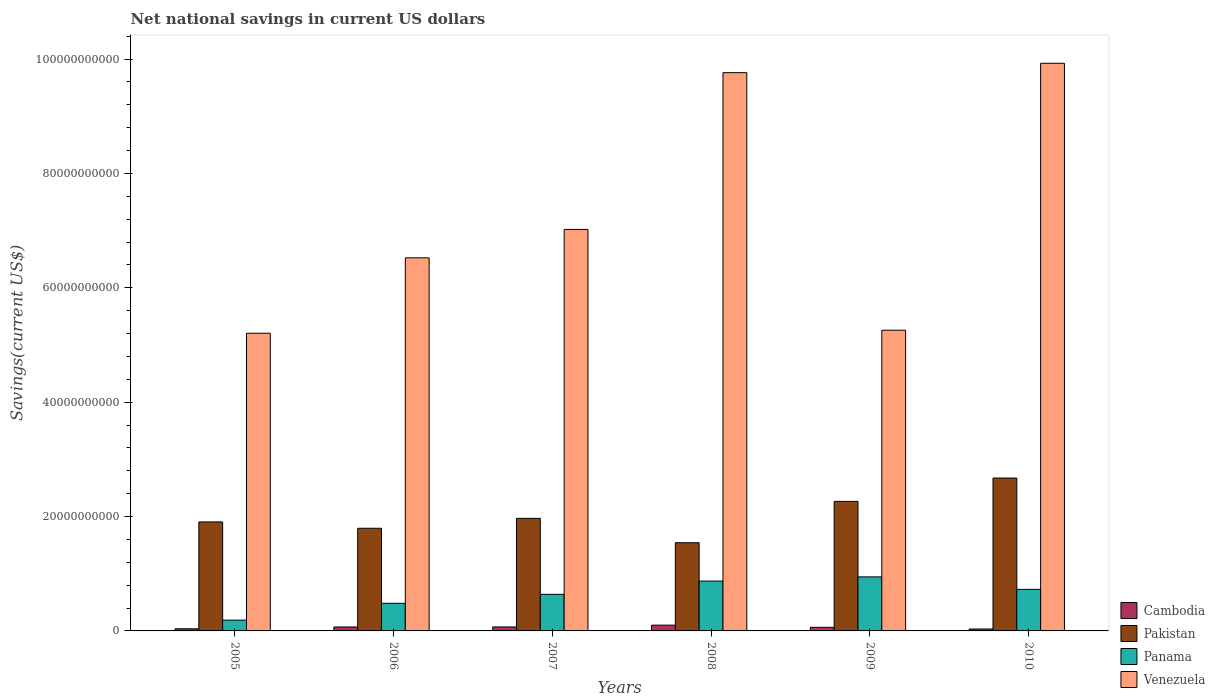How many groups of bars are there?
Provide a short and direct response. 6. Are the number of bars on each tick of the X-axis equal?
Provide a short and direct response. Yes. In how many cases, is the number of bars for a given year not equal to the number of legend labels?
Keep it short and to the point. 0. What is the net national savings in Venezuela in 2008?
Your answer should be compact. 9.76e+1. Across all years, what is the maximum net national savings in Pakistan?
Offer a terse response. 2.67e+1. Across all years, what is the minimum net national savings in Cambodia?
Your answer should be compact. 3.38e+08. In which year was the net national savings in Cambodia minimum?
Provide a succinct answer. 2010. What is the total net national savings in Panama in the graph?
Keep it short and to the point. 3.85e+1. What is the difference between the net national savings in Pakistan in 2006 and that in 2008?
Your answer should be very brief. 2.53e+09. What is the difference between the net national savings in Panama in 2005 and the net national savings in Venezuela in 2006?
Your answer should be very brief. -6.33e+1. What is the average net national savings in Pakistan per year?
Give a very brief answer. 2.02e+1. In the year 2008, what is the difference between the net national savings in Cambodia and net national savings in Pakistan?
Offer a very short reply. -1.44e+1. In how many years, is the net national savings in Cambodia greater than 88000000000 US$?
Give a very brief answer. 0. What is the ratio of the net national savings in Cambodia in 2006 to that in 2009?
Give a very brief answer. 1.09. Is the net national savings in Pakistan in 2008 less than that in 2010?
Give a very brief answer. Yes. What is the difference between the highest and the second highest net national savings in Venezuela?
Give a very brief answer. 1.64e+09. What is the difference between the highest and the lowest net national savings in Venezuela?
Make the answer very short. 4.72e+1. In how many years, is the net national savings in Venezuela greater than the average net national savings in Venezuela taken over all years?
Your answer should be very brief. 2. What does the 2nd bar from the right in 2006 represents?
Your answer should be compact. Panama. Is it the case that in every year, the sum of the net national savings in Cambodia and net national savings in Panama is greater than the net national savings in Venezuela?
Keep it short and to the point. No. How many bars are there?
Offer a very short reply. 24. Are all the bars in the graph horizontal?
Your response must be concise. No. What is the difference between two consecutive major ticks on the Y-axis?
Ensure brevity in your answer.  2.00e+1. Does the graph contain grids?
Keep it short and to the point. No. What is the title of the graph?
Your response must be concise. Net national savings in current US dollars. What is the label or title of the Y-axis?
Ensure brevity in your answer.  Savings(current US$). What is the Savings(current US$) in Cambodia in 2005?
Your response must be concise. 3.74e+08. What is the Savings(current US$) of Pakistan in 2005?
Your response must be concise. 1.91e+1. What is the Savings(current US$) of Panama in 2005?
Provide a succinct answer. 1.89e+09. What is the Savings(current US$) in Venezuela in 2005?
Provide a short and direct response. 5.20e+1. What is the Savings(current US$) in Cambodia in 2006?
Your answer should be compact. 6.89e+08. What is the Savings(current US$) in Pakistan in 2006?
Offer a very short reply. 1.79e+1. What is the Savings(current US$) of Panama in 2006?
Offer a very short reply. 4.83e+09. What is the Savings(current US$) of Venezuela in 2006?
Offer a very short reply. 6.52e+1. What is the Savings(current US$) in Cambodia in 2007?
Your answer should be compact. 6.94e+08. What is the Savings(current US$) of Pakistan in 2007?
Your response must be concise. 1.97e+1. What is the Savings(current US$) of Panama in 2007?
Provide a succinct answer. 6.40e+09. What is the Savings(current US$) in Venezuela in 2007?
Provide a short and direct response. 7.02e+1. What is the Savings(current US$) in Cambodia in 2008?
Ensure brevity in your answer.  1.01e+09. What is the Savings(current US$) in Pakistan in 2008?
Give a very brief answer. 1.54e+1. What is the Savings(current US$) of Panama in 2008?
Keep it short and to the point. 8.71e+09. What is the Savings(current US$) in Venezuela in 2008?
Provide a short and direct response. 9.76e+1. What is the Savings(current US$) in Cambodia in 2009?
Your answer should be very brief. 6.31e+08. What is the Savings(current US$) of Pakistan in 2009?
Keep it short and to the point. 2.26e+1. What is the Savings(current US$) in Panama in 2009?
Provide a short and direct response. 9.45e+09. What is the Savings(current US$) in Venezuela in 2009?
Keep it short and to the point. 5.26e+1. What is the Savings(current US$) of Cambodia in 2010?
Give a very brief answer. 3.38e+08. What is the Savings(current US$) of Pakistan in 2010?
Your response must be concise. 2.67e+1. What is the Savings(current US$) of Panama in 2010?
Your answer should be compact. 7.27e+09. What is the Savings(current US$) in Venezuela in 2010?
Offer a very short reply. 9.93e+1. Across all years, what is the maximum Savings(current US$) of Cambodia?
Provide a succinct answer. 1.01e+09. Across all years, what is the maximum Savings(current US$) in Pakistan?
Keep it short and to the point. 2.67e+1. Across all years, what is the maximum Savings(current US$) of Panama?
Your answer should be compact. 9.45e+09. Across all years, what is the maximum Savings(current US$) in Venezuela?
Offer a terse response. 9.93e+1. Across all years, what is the minimum Savings(current US$) of Cambodia?
Offer a terse response. 3.38e+08. Across all years, what is the minimum Savings(current US$) of Pakistan?
Your response must be concise. 1.54e+1. Across all years, what is the minimum Savings(current US$) of Panama?
Make the answer very short. 1.89e+09. Across all years, what is the minimum Savings(current US$) in Venezuela?
Offer a very short reply. 5.20e+1. What is the total Savings(current US$) in Cambodia in the graph?
Your answer should be very brief. 3.74e+09. What is the total Savings(current US$) of Pakistan in the graph?
Make the answer very short. 1.21e+11. What is the total Savings(current US$) in Panama in the graph?
Your answer should be compact. 3.85e+1. What is the total Savings(current US$) in Venezuela in the graph?
Keep it short and to the point. 4.37e+11. What is the difference between the Savings(current US$) in Cambodia in 2005 and that in 2006?
Your answer should be compact. -3.15e+08. What is the difference between the Savings(current US$) in Pakistan in 2005 and that in 2006?
Your answer should be compact. 1.11e+09. What is the difference between the Savings(current US$) of Panama in 2005 and that in 2006?
Offer a terse response. -2.94e+09. What is the difference between the Savings(current US$) of Venezuela in 2005 and that in 2006?
Provide a succinct answer. -1.32e+1. What is the difference between the Savings(current US$) in Cambodia in 2005 and that in 2007?
Provide a short and direct response. -3.20e+08. What is the difference between the Savings(current US$) in Pakistan in 2005 and that in 2007?
Give a very brief answer. -6.23e+08. What is the difference between the Savings(current US$) of Panama in 2005 and that in 2007?
Offer a very short reply. -4.51e+09. What is the difference between the Savings(current US$) of Venezuela in 2005 and that in 2007?
Provide a short and direct response. -1.82e+1. What is the difference between the Savings(current US$) of Cambodia in 2005 and that in 2008?
Provide a short and direct response. -6.35e+08. What is the difference between the Savings(current US$) of Pakistan in 2005 and that in 2008?
Provide a short and direct response. 3.64e+09. What is the difference between the Savings(current US$) of Panama in 2005 and that in 2008?
Give a very brief answer. -6.82e+09. What is the difference between the Savings(current US$) of Venezuela in 2005 and that in 2008?
Keep it short and to the point. -4.56e+1. What is the difference between the Savings(current US$) of Cambodia in 2005 and that in 2009?
Keep it short and to the point. -2.57e+08. What is the difference between the Savings(current US$) in Pakistan in 2005 and that in 2009?
Offer a very short reply. -3.59e+09. What is the difference between the Savings(current US$) in Panama in 2005 and that in 2009?
Provide a short and direct response. -7.56e+09. What is the difference between the Savings(current US$) of Venezuela in 2005 and that in 2009?
Offer a very short reply. -5.31e+08. What is the difference between the Savings(current US$) of Cambodia in 2005 and that in 2010?
Provide a short and direct response. 3.62e+07. What is the difference between the Savings(current US$) in Pakistan in 2005 and that in 2010?
Your response must be concise. -7.67e+09. What is the difference between the Savings(current US$) in Panama in 2005 and that in 2010?
Make the answer very short. -5.38e+09. What is the difference between the Savings(current US$) in Venezuela in 2005 and that in 2010?
Ensure brevity in your answer.  -4.72e+1. What is the difference between the Savings(current US$) in Cambodia in 2006 and that in 2007?
Offer a terse response. -5.39e+06. What is the difference between the Savings(current US$) of Pakistan in 2006 and that in 2007?
Your answer should be compact. -1.73e+09. What is the difference between the Savings(current US$) of Panama in 2006 and that in 2007?
Your response must be concise. -1.57e+09. What is the difference between the Savings(current US$) of Venezuela in 2006 and that in 2007?
Your response must be concise. -4.97e+09. What is the difference between the Savings(current US$) in Cambodia in 2006 and that in 2008?
Your answer should be compact. -3.21e+08. What is the difference between the Savings(current US$) in Pakistan in 2006 and that in 2008?
Ensure brevity in your answer.  2.53e+09. What is the difference between the Savings(current US$) in Panama in 2006 and that in 2008?
Offer a very short reply. -3.88e+09. What is the difference between the Savings(current US$) in Venezuela in 2006 and that in 2008?
Give a very brief answer. -3.24e+1. What is the difference between the Savings(current US$) of Cambodia in 2006 and that in 2009?
Give a very brief answer. 5.73e+07. What is the difference between the Savings(current US$) of Pakistan in 2006 and that in 2009?
Make the answer very short. -4.70e+09. What is the difference between the Savings(current US$) of Panama in 2006 and that in 2009?
Your answer should be very brief. -4.62e+09. What is the difference between the Savings(current US$) of Venezuela in 2006 and that in 2009?
Offer a very short reply. 1.27e+1. What is the difference between the Savings(current US$) of Cambodia in 2006 and that in 2010?
Make the answer very short. 3.51e+08. What is the difference between the Savings(current US$) of Pakistan in 2006 and that in 2010?
Offer a very short reply. -8.78e+09. What is the difference between the Savings(current US$) in Panama in 2006 and that in 2010?
Your answer should be very brief. -2.43e+09. What is the difference between the Savings(current US$) in Venezuela in 2006 and that in 2010?
Ensure brevity in your answer.  -3.40e+1. What is the difference between the Savings(current US$) in Cambodia in 2007 and that in 2008?
Provide a succinct answer. -3.15e+08. What is the difference between the Savings(current US$) of Pakistan in 2007 and that in 2008?
Provide a succinct answer. 4.26e+09. What is the difference between the Savings(current US$) of Panama in 2007 and that in 2008?
Ensure brevity in your answer.  -2.31e+09. What is the difference between the Savings(current US$) in Venezuela in 2007 and that in 2008?
Give a very brief answer. -2.74e+1. What is the difference between the Savings(current US$) of Cambodia in 2007 and that in 2009?
Offer a very short reply. 6.27e+07. What is the difference between the Savings(current US$) in Pakistan in 2007 and that in 2009?
Ensure brevity in your answer.  -2.97e+09. What is the difference between the Savings(current US$) of Panama in 2007 and that in 2009?
Your answer should be compact. -3.05e+09. What is the difference between the Savings(current US$) of Venezuela in 2007 and that in 2009?
Your answer should be compact. 1.76e+1. What is the difference between the Savings(current US$) in Cambodia in 2007 and that in 2010?
Provide a short and direct response. 3.56e+08. What is the difference between the Savings(current US$) in Pakistan in 2007 and that in 2010?
Offer a terse response. -7.05e+09. What is the difference between the Savings(current US$) of Panama in 2007 and that in 2010?
Offer a terse response. -8.69e+08. What is the difference between the Savings(current US$) in Venezuela in 2007 and that in 2010?
Make the answer very short. -2.91e+1. What is the difference between the Savings(current US$) of Cambodia in 2008 and that in 2009?
Offer a terse response. 3.78e+08. What is the difference between the Savings(current US$) in Pakistan in 2008 and that in 2009?
Offer a terse response. -7.23e+09. What is the difference between the Savings(current US$) of Panama in 2008 and that in 2009?
Give a very brief answer. -7.36e+08. What is the difference between the Savings(current US$) of Venezuela in 2008 and that in 2009?
Provide a succinct answer. 4.50e+1. What is the difference between the Savings(current US$) in Cambodia in 2008 and that in 2010?
Your answer should be very brief. 6.71e+08. What is the difference between the Savings(current US$) in Pakistan in 2008 and that in 2010?
Offer a very short reply. -1.13e+1. What is the difference between the Savings(current US$) of Panama in 2008 and that in 2010?
Offer a very short reply. 1.45e+09. What is the difference between the Savings(current US$) of Venezuela in 2008 and that in 2010?
Offer a terse response. -1.64e+09. What is the difference between the Savings(current US$) of Cambodia in 2009 and that in 2010?
Ensure brevity in your answer.  2.93e+08. What is the difference between the Savings(current US$) in Pakistan in 2009 and that in 2010?
Ensure brevity in your answer.  -4.08e+09. What is the difference between the Savings(current US$) of Panama in 2009 and that in 2010?
Give a very brief answer. 2.18e+09. What is the difference between the Savings(current US$) in Venezuela in 2009 and that in 2010?
Ensure brevity in your answer.  -4.67e+1. What is the difference between the Savings(current US$) in Cambodia in 2005 and the Savings(current US$) in Pakistan in 2006?
Ensure brevity in your answer.  -1.76e+1. What is the difference between the Savings(current US$) in Cambodia in 2005 and the Savings(current US$) in Panama in 2006?
Offer a terse response. -4.46e+09. What is the difference between the Savings(current US$) of Cambodia in 2005 and the Savings(current US$) of Venezuela in 2006?
Your response must be concise. -6.49e+1. What is the difference between the Savings(current US$) in Pakistan in 2005 and the Savings(current US$) in Panama in 2006?
Offer a very short reply. 1.42e+1. What is the difference between the Savings(current US$) in Pakistan in 2005 and the Savings(current US$) in Venezuela in 2006?
Ensure brevity in your answer.  -4.62e+1. What is the difference between the Savings(current US$) of Panama in 2005 and the Savings(current US$) of Venezuela in 2006?
Give a very brief answer. -6.33e+1. What is the difference between the Savings(current US$) in Cambodia in 2005 and the Savings(current US$) in Pakistan in 2007?
Provide a succinct answer. -1.93e+1. What is the difference between the Savings(current US$) in Cambodia in 2005 and the Savings(current US$) in Panama in 2007?
Your answer should be very brief. -6.02e+09. What is the difference between the Savings(current US$) in Cambodia in 2005 and the Savings(current US$) in Venezuela in 2007?
Provide a succinct answer. -6.98e+1. What is the difference between the Savings(current US$) in Pakistan in 2005 and the Savings(current US$) in Panama in 2007?
Your answer should be very brief. 1.27e+1. What is the difference between the Savings(current US$) of Pakistan in 2005 and the Savings(current US$) of Venezuela in 2007?
Your answer should be very brief. -5.11e+1. What is the difference between the Savings(current US$) in Panama in 2005 and the Savings(current US$) in Venezuela in 2007?
Your response must be concise. -6.83e+1. What is the difference between the Savings(current US$) in Cambodia in 2005 and the Savings(current US$) in Pakistan in 2008?
Ensure brevity in your answer.  -1.50e+1. What is the difference between the Savings(current US$) of Cambodia in 2005 and the Savings(current US$) of Panama in 2008?
Your answer should be compact. -8.34e+09. What is the difference between the Savings(current US$) of Cambodia in 2005 and the Savings(current US$) of Venezuela in 2008?
Keep it short and to the point. -9.72e+1. What is the difference between the Savings(current US$) in Pakistan in 2005 and the Savings(current US$) in Panama in 2008?
Your answer should be compact. 1.03e+1. What is the difference between the Savings(current US$) of Pakistan in 2005 and the Savings(current US$) of Venezuela in 2008?
Provide a short and direct response. -7.86e+1. What is the difference between the Savings(current US$) of Panama in 2005 and the Savings(current US$) of Venezuela in 2008?
Provide a short and direct response. -9.57e+1. What is the difference between the Savings(current US$) of Cambodia in 2005 and the Savings(current US$) of Pakistan in 2009?
Your answer should be very brief. -2.23e+1. What is the difference between the Savings(current US$) of Cambodia in 2005 and the Savings(current US$) of Panama in 2009?
Give a very brief answer. -9.07e+09. What is the difference between the Savings(current US$) in Cambodia in 2005 and the Savings(current US$) in Venezuela in 2009?
Offer a very short reply. -5.22e+1. What is the difference between the Savings(current US$) of Pakistan in 2005 and the Savings(current US$) of Panama in 2009?
Make the answer very short. 9.61e+09. What is the difference between the Savings(current US$) of Pakistan in 2005 and the Savings(current US$) of Venezuela in 2009?
Your answer should be compact. -3.35e+1. What is the difference between the Savings(current US$) of Panama in 2005 and the Savings(current US$) of Venezuela in 2009?
Ensure brevity in your answer.  -5.07e+1. What is the difference between the Savings(current US$) of Cambodia in 2005 and the Savings(current US$) of Pakistan in 2010?
Offer a very short reply. -2.64e+1. What is the difference between the Savings(current US$) in Cambodia in 2005 and the Savings(current US$) in Panama in 2010?
Make the answer very short. -6.89e+09. What is the difference between the Savings(current US$) in Cambodia in 2005 and the Savings(current US$) in Venezuela in 2010?
Give a very brief answer. -9.89e+1. What is the difference between the Savings(current US$) in Pakistan in 2005 and the Savings(current US$) in Panama in 2010?
Your answer should be compact. 1.18e+1. What is the difference between the Savings(current US$) of Pakistan in 2005 and the Savings(current US$) of Venezuela in 2010?
Make the answer very short. -8.02e+1. What is the difference between the Savings(current US$) in Panama in 2005 and the Savings(current US$) in Venezuela in 2010?
Your response must be concise. -9.74e+1. What is the difference between the Savings(current US$) of Cambodia in 2006 and the Savings(current US$) of Pakistan in 2007?
Ensure brevity in your answer.  -1.90e+1. What is the difference between the Savings(current US$) of Cambodia in 2006 and the Savings(current US$) of Panama in 2007?
Offer a very short reply. -5.71e+09. What is the difference between the Savings(current US$) in Cambodia in 2006 and the Savings(current US$) in Venezuela in 2007?
Give a very brief answer. -6.95e+1. What is the difference between the Savings(current US$) of Pakistan in 2006 and the Savings(current US$) of Panama in 2007?
Give a very brief answer. 1.16e+1. What is the difference between the Savings(current US$) of Pakistan in 2006 and the Savings(current US$) of Venezuela in 2007?
Offer a very short reply. -5.23e+1. What is the difference between the Savings(current US$) in Panama in 2006 and the Savings(current US$) in Venezuela in 2007?
Offer a very short reply. -6.54e+1. What is the difference between the Savings(current US$) of Cambodia in 2006 and the Savings(current US$) of Pakistan in 2008?
Ensure brevity in your answer.  -1.47e+1. What is the difference between the Savings(current US$) in Cambodia in 2006 and the Savings(current US$) in Panama in 2008?
Provide a short and direct response. -8.02e+09. What is the difference between the Savings(current US$) in Cambodia in 2006 and the Savings(current US$) in Venezuela in 2008?
Give a very brief answer. -9.69e+1. What is the difference between the Savings(current US$) in Pakistan in 2006 and the Savings(current US$) in Panama in 2008?
Your answer should be compact. 9.24e+09. What is the difference between the Savings(current US$) in Pakistan in 2006 and the Savings(current US$) in Venezuela in 2008?
Make the answer very short. -7.97e+1. What is the difference between the Savings(current US$) of Panama in 2006 and the Savings(current US$) of Venezuela in 2008?
Your answer should be compact. -9.28e+1. What is the difference between the Savings(current US$) in Cambodia in 2006 and the Savings(current US$) in Pakistan in 2009?
Your response must be concise. -2.20e+1. What is the difference between the Savings(current US$) in Cambodia in 2006 and the Savings(current US$) in Panama in 2009?
Give a very brief answer. -8.76e+09. What is the difference between the Savings(current US$) in Cambodia in 2006 and the Savings(current US$) in Venezuela in 2009?
Make the answer very short. -5.19e+1. What is the difference between the Savings(current US$) of Pakistan in 2006 and the Savings(current US$) of Panama in 2009?
Provide a succinct answer. 8.50e+09. What is the difference between the Savings(current US$) in Pakistan in 2006 and the Savings(current US$) in Venezuela in 2009?
Your answer should be compact. -3.46e+1. What is the difference between the Savings(current US$) of Panama in 2006 and the Savings(current US$) of Venezuela in 2009?
Offer a terse response. -4.77e+1. What is the difference between the Savings(current US$) of Cambodia in 2006 and the Savings(current US$) of Pakistan in 2010?
Your answer should be very brief. -2.60e+1. What is the difference between the Savings(current US$) in Cambodia in 2006 and the Savings(current US$) in Panama in 2010?
Your answer should be very brief. -6.58e+09. What is the difference between the Savings(current US$) of Cambodia in 2006 and the Savings(current US$) of Venezuela in 2010?
Your answer should be compact. -9.86e+1. What is the difference between the Savings(current US$) of Pakistan in 2006 and the Savings(current US$) of Panama in 2010?
Give a very brief answer. 1.07e+1. What is the difference between the Savings(current US$) of Pakistan in 2006 and the Savings(current US$) of Venezuela in 2010?
Provide a succinct answer. -8.13e+1. What is the difference between the Savings(current US$) of Panama in 2006 and the Savings(current US$) of Venezuela in 2010?
Offer a terse response. -9.44e+1. What is the difference between the Savings(current US$) of Cambodia in 2007 and the Savings(current US$) of Pakistan in 2008?
Make the answer very short. -1.47e+1. What is the difference between the Savings(current US$) in Cambodia in 2007 and the Savings(current US$) in Panama in 2008?
Offer a very short reply. -8.02e+09. What is the difference between the Savings(current US$) in Cambodia in 2007 and the Savings(current US$) in Venezuela in 2008?
Your answer should be very brief. -9.69e+1. What is the difference between the Savings(current US$) of Pakistan in 2007 and the Savings(current US$) of Panama in 2008?
Ensure brevity in your answer.  1.10e+1. What is the difference between the Savings(current US$) in Pakistan in 2007 and the Savings(current US$) in Venezuela in 2008?
Provide a succinct answer. -7.79e+1. What is the difference between the Savings(current US$) in Panama in 2007 and the Savings(current US$) in Venezuela in 2008?
Offer a terse response. -9.12e+1. What is the difference between the Savings(current US$) in Cambodia in 2007 and the Savings(current US$) in Pakistan in 2009?
Ensure brevity in your answer.  -2.20e+1. What is the difference between the Savings(current US$) of Cambodia in 2007 and the Savings(current US$) of Panama in 2009?
Ensure brevity in your answer.  -8.75e+09. What is the difference between the Savings(current US$) in Cambodia in 2007 and the Savings(current US$) in Venezuela in 2009?
Offer a very short reply. -5.19e+1. What is the difference between the Savings(current US$) of Pakistan in 2007 and the Savings(current US$) of Panama in 2009?
Provide a short and direct response. 1.02e+1. What is the difference between the Savings(current US$) in Pakistan in 2007 and the Savings(current US$) in Venezuela in 2009?
Make the answer very short. -3.29e+1. What is the difference between the Savings(current US$) of Panama in 2007 and the Savings(current US$) of Venezuela in 2009?
Ensure brevity in your answer.  -4.62e+1. What is the difference between the Savings(current US$) in Cambodia in 2007 and the Savings(current US$) in Pakistan in 2010?
Offer a terse response. -2.60e+1. What is the difference between the Savings(current US$) in Cambodia in 2007 and the Savings(current US$) in Panama in 2010?
Provide a short and direct response. -6.57e+09. What is the difference between the Savings(current US$) in Cambodia in 2007 and the Savings(current US$) in Venezuela in 2010?
Your answer should be compact. -9.86e+1. What is the difference between the Savings(current US$) in Pakistan in 2007 and the Savings(current US$) in Panama in 2010?
Your answer should be compact. 1.24e+1. What is the difference between the Savings(current US$) of Pakistan in 2007 and the Savings(current US$) of Venezuela in 2010?
Keep it short and to the point. -7.96e+1. What is the difference between the Savings(current US$) in Panama in 2007 and the Savings(current US$) in Venezuela in 2010?
Provide a succinct answer. -9.29e+1. What is the difference between the Savings(current US$) of Cambodia in 2008 and the Savings(current US$) of Pakistan in 2009?
Your answer should be compact. -2.16e+1. What is the difference between the Savings(current US$) in Cambodia in 2008 and the Savings(current US$) in Panama in 2009?
Keep it short and to the point. -8.44e+09. What is the difference between the Savings(current US$) of Cambodia in 2008 and the Savings(current US$) of Venezuela in 2009?
Ensure brevity in your answer.  -5.16e+1. What is the difference between the Savings(current US$) of Pakistan in 2008 and the Savings(current US$) of Panama in 2009?
Offer a very short reply. 5.97e+09. What is the difference between the Savings(current US$) in Pakistan in 2008 and the Savings(current US$) in Venezuela in 2009?
Provide a short and direct response. -3.72e+1. What is the difference between the Savings(current US$) in Panama in 2008 and the Savings(current US$) in Venezuela in 2009?
Make the answer very short. -4.39e+1. What is the difference between the Savings(current US$) in Cambodia in 2008 and the Savings(current US$) in Pakistan in 2010?
Provide a short and direct response. -2.57e+1. What is the difference between the Savings(current US$) of Cambodia in 2008 and the Savings(current US$) of Panama in 2010?
Give a very brief answer. -6.26e+09. What is the difference between the Savings(current US$) in Cambodia in 2008 and the Savings(current US$) in Venezuela in 2010?
Offer a very short reply. -9.82e+1. What is the difference between the Savings(current US$) of Pakistan in 2008 and the Savings(current US$) of Panama in 2010?
Offer a very short reply. 8.15e+09. What is the difference between the Savings(current US$) of Pakistan in 2008 and the Savings(current US$) of Venezuela in 2010?
Keep it short and to the point. -8.38e+1. What is the difference between the Savings(current US$) in Panama in 2008 and the Savings(current US$) in Venezuela in 2010?
Your answer should be very brief. -9.05e+1. What is the difference between the Savings(current US$) in Cambodia in 2009 and the Savings(current US$) in Pakistan in 2010?
Provide a succinct answer. -2.61e+1. What is the difference between the Savings(current US$) in Cambodia in 2009 and the Savings(current US$) in Panama in 2010?
Provide a succinct answer. -6.64e+09. What is the difference between the Savings(current US$) in Cambodia in 2009 and the Savings(current US$) in Venezuela in 2010?
Your answer should be compact. -9.86e+1. What is the difference between the Savings(current US$) in Pakistan in 2009 and the Savings(current US$) in Panama in 2010?
Your response must be concise. 1.54e+1. What is the difference between the Savings(current US$) of Pakistan in 2009 and the Savings(current US$) of Venezuela in 2010?
Your answer should be compact. -7.66e+1. What is the difference between the Savings(current US$) of Panama in 2009 and the Savings(current US$) of Venezuela in 2010?
Give a very brief answer. -8.98e+1. What is the average Savings(current US$) in Cambodia per year?
Provide a short and direct response. 6.23e+08. What is the average Savings(current US$) in Pakistan per year?
Your answer should be compact. 2.02e+1. What is the average Savings(current US$) in Panama per year?
Give a very brief answer. 6.42e+09. What is the average Savings(current US$) in Venezuela per year?
Your answer should be very brief. 7.28e+1. In the year 2005, what is the difference between the Savings(current US$) of Cambodia and Savings(current US$) of Pakistan?
Provide a succinct answer. -1.87e+1. In the year 2005, what is the difference between the Savings(current US$) of Cambodia and Savings(current US$) of Panama?
Provide a succinct answer. -1.52e+09. In the year 2005, what is the difference between the Savings(current US$) in Cambodia and Savings(current US$) in Venezuela?
Provide a short and direct response. -5.17e+1. In the year 2005, what is the difference between the Savings(current US$) of Pakistan and Savings(current US$) of Panama?
Provide a short and direct response. 1.72e+1. In the year 2005, what is the difference between the Savings(current US$) in Pakistan and Savings(current US$) in Venezuela?
Your answer should be very brief. -3.30e+1. In the year 2005, what is the difference between the Savings(current US$) of Panama and Savings(current US$) of Venezuela?
Give a very brief answer. -5.02e+1. In the year 2006, what is the difference between the Savings(current US$) of Cambodia and Savings(current US$) of Pakistan?
Ensure brevity in your answer.  -1.73e+1. In the year 2006, what is the difference between the Savings(current US$) of Cambodia and Savings(current US$) of Panama?
Offer a very short reply. -4.14e+09. In the year 2006, what is the difference between the Savings(current US$) in Cambodia and Savings(current US$) in Venezuela?
Keep it short and to the point. -6.45e+1. In the year 2006, what is the difference between the Savings(current US$) in Pakistan and Savings(current US$) in Panama?
Provide a succinct answer. 1.31e+1. In the year 2006, what is the difference between the Savings(current US$) in Pakistan and Savings(current US$) in Venezuela?
Provide a short and direct response. -4.73e+1. In the year 2006, what is the difference between the Savings(current US$) of Panama and Savings(current US$) of Venezuela?
Give a very brief answer. -6.04e+1. In the year 2007, what is the difference between the Savings(current US$) of Cambodia and Savings(current US$) of Pakistan?
Your answer should be compact. -1.90e+1. In the year 2007, what is the difference between the Savings(current US$) of Cambodia and Savings(current US$) of Panama?
Make the answer very short. -5.70e+09. In the year 2007, what is the difference between the Savings(current US$) in Cambodia and Savings(current US$) in Venezuela?
Your answer should be very brief. -6.95e+1. In the year 2007, what is the difference between the Savings(current US$) of Pakistan and Savings(current US$) of Panama?
Provide a succinct answer. 1.33e+1. In the year 2007, what is the difference between the Savings(current US$) in Pakistan and Savings(current US$) in Venezuela?
Make the answer very short. -5.05e+1. In the year 2007, what is the difference between the Savings(current US$) in Panama and Savings(current US$) in Venezuela?
Make the answer very short. -6.38e+1. In the year 2008, what is the difference between the Savings(current US$) in Cambodia and Savings(current US$) in Pakistan?
Keep it short and to the point. -1.44e+1. In the year 2008, what is the difference between the Savings(current US$) in Cambodia and Savings(current US$) in Panama?
Your response must be concise. -7.70e+09. In the year 2008, what is the difference between the Savings(current US$) of Cambodia and Savings(current US$) of Venezuela?
Keep it short and to the point. -9.66e+1. In the year 2008, what is the difference between the Savings(current US$) in Pakistan and Savings(current US$) in Panama?
Ensure brevity in your answer.  6.71e+09. In the year 2008, what is the difference between the Savings(current US$) of Pakistan and Savings(current US$) of Venezuela?
Offer a terse response. -8.22e+1. In the year 2008, what is the difference between the Savings(current US$) in Panama and Savings(current US$) in Venezuela?
Make the answer very short. -8.89e+1. In the year 2009, what is the difference between the Savings(current US$) of Cambodia and Savings(current US$) of Pakistan?
Make the answer very short. -2.20e+1. In the year 2009, what is the difference between the Savings(current US$) in Cambodia and Savings(current US$) in Panama?
Provide a succinct answer. -8.82e+09. In the year 2009, what is the difference between the Savings(current US$) of Cambodia and Savings(current US$) of Venezuela?
Offer a terse response. -5.19e+1. In the year 2009, what is the difference between the Savings(current US$) in Pakistan and Savings(current US$) in Panama?
Offer a very short reply. 1.32e+1. In the year 2009, what is the difference between the Savings(current US$) in Pakistan and Savings(current US$) in Venezuela?
Keep it short and to the point. -2.99e+1. In the year 2009, what is the difference between the Savings(current US$) of Panama and Savings(current US$) of Venezuela?
Provide a succinct answer. -4.31e+1. In the year 2010, what is the difference between the Savings(current US$) of Cambodia and Savings(current US$) of Pakistan?
Keep it short and to the point. -2.64e+1. In the year 2010, what is the difference between the Savings(current US$) of Cambodia and Savings(current US$) of Panama?
Ensure brevity in your answer.  -6.93e+09. In the year 2010, what is the difference between the Savings(current US$) of Cambodia and Savings(current US$) of Venezuela?
Your answer should be very brief. -9.89e+1. In the year 2010, what is the difference between the Savings(current US$) of Pakistan and Savings(current US$) of Panama?
Keep it short and to the point. 1.95e+1. In the year 2010, what is the difference between the Savings(current US$) of Pakistan and Savings(current US$) of Venezuela?
Provide a short and direct response. -7.25e+1. In the year 2010, what is the difference between the Savings(current US$) of Panama and Savings(current US$) of Venezuela?
Your answer should be very brief. -9.20e+1. What is the ratio of the Savings(current US$) in Cambodia in 2005 to that in 2006?
Your response must be concise. 0.54. What is the ratio of the Savings(current US$) of Pakistan in 2005 to that in 2006?
Provide a short and direct response. 1.06. What is the ratio of the Savings(current US$) of Panama in 2005 to that in 2006?
Your response must be concise. 0.39. What is the ratio of the Savings(current US$) in Venezuela in 2005 to that in 2006?
Provide a short and direct response. 0.8. What is the ratio of the Savings(current US$) of Cambodia in 2005 to that in 2007?
Provide a succinct answer. 0.54. What is the ratio of the Savings(current US$) in Pakistan in 2005 to that in 2007?
Provide a succinct answer. 0.97. What is the ratio of the Savings(current US$) of Panama in 2005 to that in 2007?
Provide a succinct answer. 0.3. What is the ratio of the Savings(current US$) in Venezuela in 2005 to that in 2007?
Keep it short and to the point. 0.74. What is the ratio of the Savings(current US$) of Cambodia in 2005 to that in 2008?
Your answer should be compact. 0.37. What is the ratio of the Savings(current US$) in Pakistan in 2005 to that in 2008?
Offer a very short reply. 1.24. What is the ratio of the Savings(current US$) in Panama in 2005 to that in 2008?
Your answer should be compact. 0.22. What is the ratio of the Savings(current US$) in Venezuela in 2005 to that in 2008?
Give a very brief answer. 0.53. What is the ratio of the Savings(current US$) in Cambodia in 2005 to that in 2009?
Make the answer very short. 0.59. What is the ratio of the Savings(current US$) in Pakistan in 2005 to that in 2009?
Your answer should be compact. 0.84. What is the ratio of the Savings(current US$) in Cambodia in 2005 to that in 2010?
Ensure brevity in your answer.  1.11. What is the ratio of the Savings(current US$) in Pakistan in 2005 to that in 2010?
Make the answer very short. 0.71. What is the ratio of the Savings(current US$) of Panama in 2005 to that in 2010?
Keep it short and to the point. 0.26. What is the ratio of the Savings(current US$) of Venezuela in 2005 to that in 2010?
Give a very brief answer. 0.52. What is the ratio of the Savings(current US$) in Cambodia in 2006 to that in 2007?
Give a very brief answer. 0.99. What is the ratio of the Savings(current US$) in Pakistan in 2006 to that in 2007?
Offer a terse response. 0.91. What is the ratio of the Savings(current US$) of Panama in 2006 to that in 2007?
Keep it short and to the point. 0.76. What is the ratio of the Savings(current US$) in Venezuela in 2006 to that in 2007?
Offer a very short reply. 0.93. What is the ratio of the Savings(current US$) of Cambodia in 2006 to that in 2008?
Your response must be concise. 0.68. What is the ratio of the Savings(current US$) of Pakistan in 2006 to that in 2008?
Offer a very short reply. 1.16. What is the ratio of the Savings(current US$) in Panama in 2006 to that in 2008?
Your answer should be very brief. 0.55. What is the ratio of the Savings(current US$) in Venezuela in 2006 to that in 2008?
Ensure brevity in your answer.  0.67. What is the ratio of the Savings(current US$) of Cambodia in 2006 to that in 2009?
Provide a short and direct response. 1.09. What is the ratio of the Savings(current US$) in Pakistan in 2006 to that in 2009?
Keep it short and to the point. 0.79. What is the ratio of the Savings(current US$) of Panama in 2006 to that in 2009?
Provide a succinct answer. 0.51. What is the ratio of the Savings(current US$) in Venezuela in 2006 to that in 2009?
Provide a succinct answer. 1.24. What is the ratio of the Savings(current US$) in Cambodia in 2006 to that in 2010?
Keep it short and to the point. 2.04. What is the ratio of the Savings(current US$) of Pakistan in 2006 to that in 2010?
Offer a terse response. 0.67. What is the ratio of the Savings(current US$) in Panama in 2006 to that in 2010?
Keep it short and to the point. 0.66. What is the ratio of the Savings(current US$) of Venezuela in 2006 to that in 2010?
Ensure brevity in your answer.  0.66. What is the ratio of the Savings(current US$) of Cambodia in 2007 to that in 2008?
Your response must be concise. 0.69. What is the ratio of the Savings(current US$) in Pakistan in 2007 to that in 2008?
Give a very brief answer. 1.28. What is the ratio of the Savings(current US$) of Panama in 2007 to that in 2008?
Your response must be concise. 0.73. What is the ratio of the Savings(current US$) in Venezuela in 2007 to that in 2008?
Make the answer very short. 0.72. What is the ratio of the Savings(current US$) in Cambodia in 2007 to that in 2009?
Give a very brief answer. 1.1. What is the ratio of the Savings(current US$) in Pakistan in 2007 to that in 2009?
Provide a succinct answer. 0.87. What is the ratio of the Savings(current US$) of Panama in 2007 to that in 2009?
Offer a very short reply. 0.68. What is the ratio of the Savings(current US$) of Venezuela in 2007 to that in 2009?
Offer a very short reply. 1.34. What is the ratio of the Savings(current US$) of Cambodia in 2007 to that in 2010?
Your answer should be very brief. 2.05. What is the ratio of the Savings(current US$) in Pakistan in 2007 to that in 2010?
Offer a terse response. 0.74. What is the ratio of the Savings(current US$) in Panama in 2007 to that in 2010?
Make the answer very short. 0.88. What is the ratio of the Savings(current US$) of Venezuela in 2007 to that in 2010?
Make the answer very short. 0.71. What is the ratio of the Savings(current US$) in Cambodia in 2008 to that in 2009?
Make the answer very short. 1.6. What is the ratio of the Savings(current US$) in Pakistan in 2008 to that in 2009?
Provide a succinct answer. 0.68. What is the ratio of the Savings(current US$) of Panama in 2008 to that in 2009?
Your answer should be very brief. 0.92. What is the ratio of the Savings(current US$) of Venezuela in 2008 to that in 2009?
Ensure brevity in your answer.  1.86. What is the ratio of the Savings(current US$) of Cambodia in 2008 to that in 2010?
Keep it short and to the point. 2.99. What is the ratio of the Savings(current US$) of Pakistan in 2008 to that in 2010?
Provide a succinct answer. 0.58. What is the ratio of the Savings(current US$) in Panama in 2008 to that in 2010?
Offer a terse response. 1.2. What is the ratio of the Savings(current US$) in Venezuela in 2008 to that in 2010?
Make the answer very short. 0.98. What is the ratio of the Savings(current US$) in Cambodia in 2009 to that in 2010?
Your response must be concise. 1.87. What is the ratio of the Savings(current US$) in Pakistan in 2009 to that in 2010?
Provide a short and direct response. 0.85. What is the ratio of the Savings(current US$) of Panama in 2009 to that in 2010?
Your response must be concise. 1.3. What is the ratio of the Savings(current US$) in Venezuela in 2009 to that in 2010?
Make the answer very short. 0.53. What is the difference between the highest and the second highest Savings(current US$) of Cambodia?
Make the answer very short. 3.15e+08. What is the difference between the highest and the second highest Savings(current US$) in Pakistan?
Your answer should be very brief. 4.08e+09. What is the difference between the highest and the second highest Savings(current US$) in Panama?
Provide a short and direct response. 7.36e+08. What is the difference between the highest and the second highest Savings(current US$) in Venezuela?
Ensure brevity in your answer.  1.64e+09. What is the difference between the highest and the lowest Savings(current US$) of Cambodia?
Your answer should be compact. 6.71e+08. What is the difference between the highest and the lowest Savings(current US$) in Pakistan?
Your answer should be compact. 1.13e+1. What is the difference between the highest and the lowest Savings(current US$) of Panama?
Offer a terse response. 7.56e+09. What is the difference between the highest and the lowest Savings(current US$) in Venezuela?
Provide a succinct answer. 4.72e+1. 